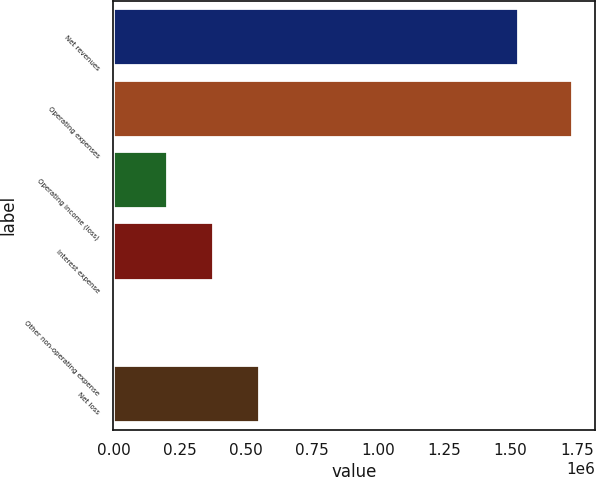Convert chart. <chart><loc_0><loc_0><loc_500><loc_500><bar_chart><fcel>Net revenues<fcel>Operating expenses<fcel>Operating income (loss)<fcel>Interest expense<fcel>Other non-operating expense<fcel>Net loss<nl><fcel>1.52736e+06<fcel>1.73126e+06<fcel>203908<fcel>376501<fcel>5329<fcel>549095<nl></chart> 